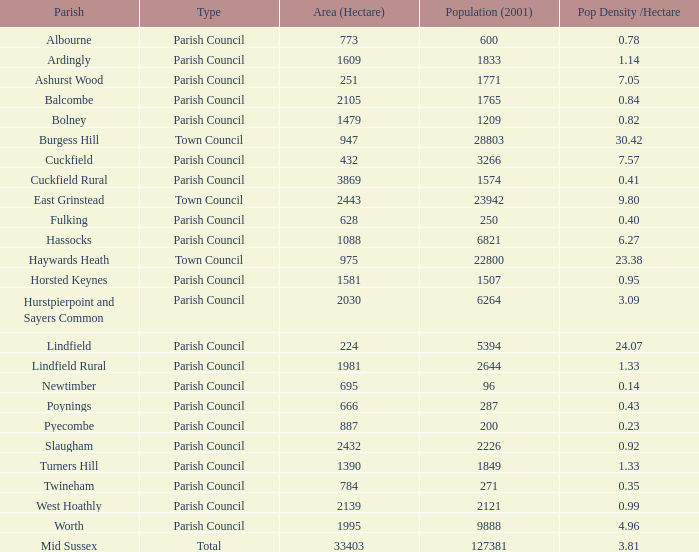What is the area for Worth Parish? 1995.0. Could you help me parse every detail presented in this table? {'header': ['Parish', 'Type', 'Area (Hectare)', 'Population (2001)', 'Pop Density /Hectare'], 'rows': [['Albourne', 'Parish Council', '773', '600', '0.78'], ['Ardingly', 'Parish Council', '1609', '1833', '1.14'], ['Ashurst Wood', 'Parish Council', '251', '1771', '7.05'], ['Balcombe', 'Parish Council', '2105', '1765', '0.84'], ['Bolney', 'Parish Council', '1479', '1209', '0.82'], ['Burgess Hill', 'Town Council', '947', '28803', '30.42'], ['Cuckfield', 'Parish Council', '432', '3266', '7.57'], ['Cuckfield Rural', 'Parish Council', '3869', '1574', '0.41'], ['East Grinstead', 'Town Council', '2443', '23942', '9.80'], ['Fulking', 'Parish Council', '628', '250', '0.40'], ['Hassocks', 'Parish Council', '1088', '6821', '6.27'], ['Haywards Heath', 'Town Council', '975', '22800', '23.38'], ['Horsted Keynes', 'Parish Council', '1581', '1507', '0.95'], ['Hurstpierpoint and Sayers Common', 'Parish Council', '2030', '6264', '3.09'], ['Lindfield', 'Parish Council', '224', '5394', '24.07'], ['Lindfield Rural', 'Parish Council', '1981', '2644', '1.33'], ['Newtimber', 'Parish Council', '695', '96', '0.14'], ['Poynings', 'Parish Council', '666', '287', '0.43'], ['Pyecombe', 'Parish Council', '887', '200', '0.23'], ['Slaugham', 'Parish Council', '2432', '2226', '0.92'], ['Turners Hill', 'Parish Council', '1390', '1849', '1.33'], ['Twineham', 'Parish Council', '784', '271', '0.35'], ['West Hoathly', 'Parish Council', '2139', '2121', '0.99'], ['Worth', 'Parish Council', '1995', '9888', '4.96'], ['Mid Sussex', 'Total', '33403', '127381', '3.81']]} 